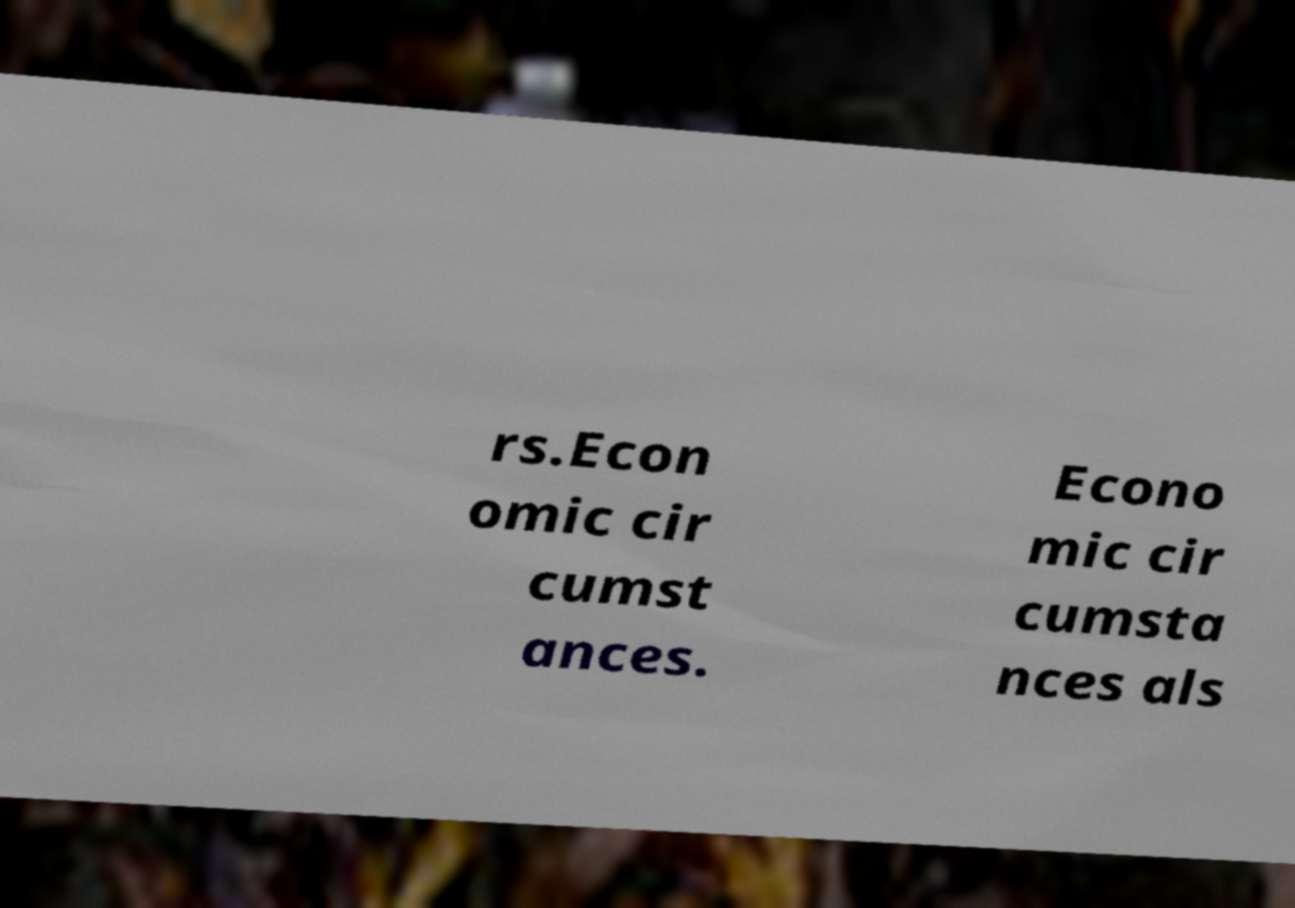Please read and relay the text visible in this image. What does it say? rs.Econ omic cir cumst ances. Econo mic cir cumsta nces als 